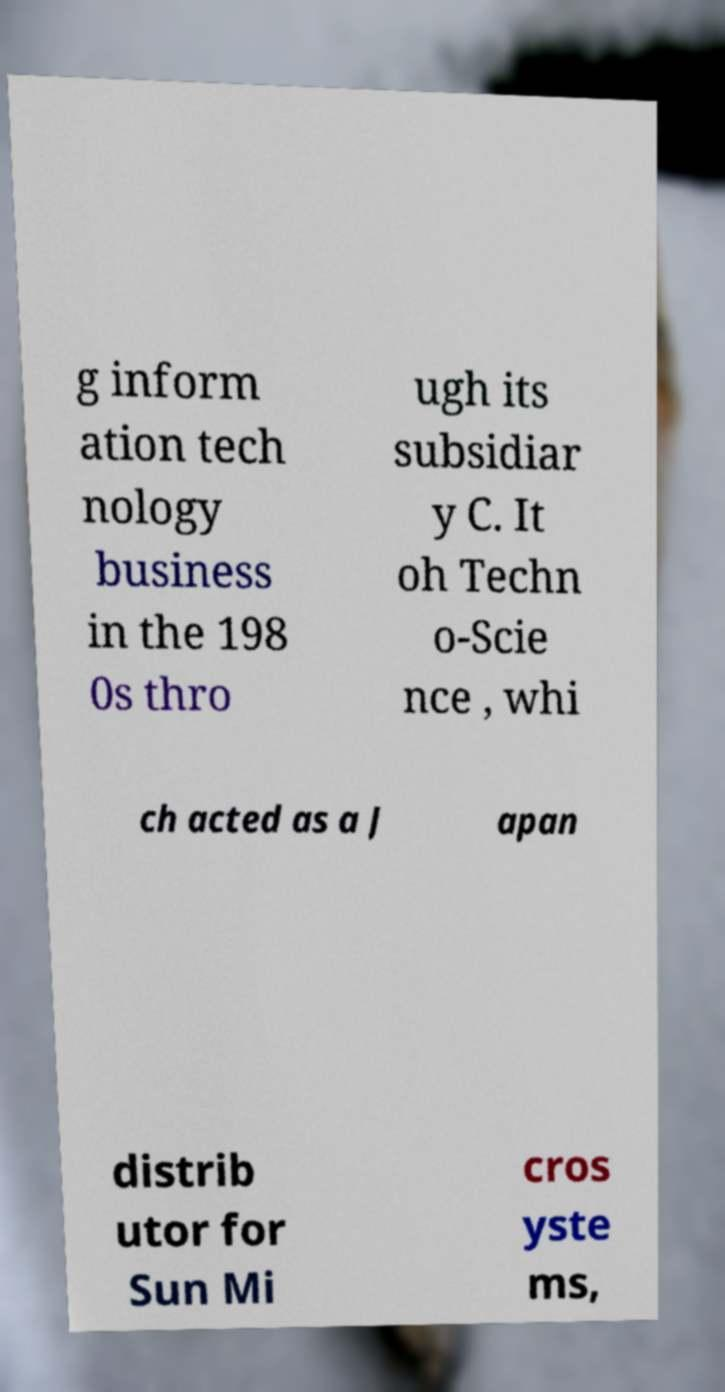What messages or text are displayed in this image? I need them in a readable, typed format. g inform ation tech nology business in the 198 0s thro ugh its subsidiar y C. It oh Techn o-Scie nce , whi ch acted as a J apan distrib utor for Sun Mi cros yste ms, 